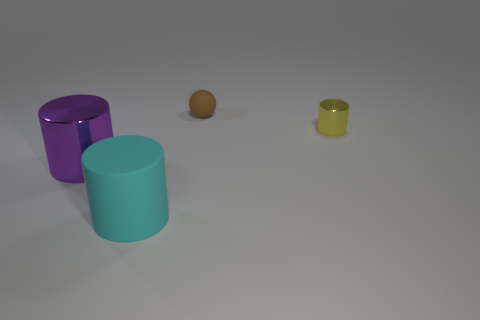Add 3 small brown matte objects. How many objects exist? 7 Subtract all cylinders. How many objects are left? 1 Add 3 brown spheres. How many brown spheres are left? 4 Add 3 brown objects. How many brown objects exist? 4 Subtract 0 blue cubes. How many objects are left? 4 Subtract all blue objects. Subtract all tiny yellow objects. How many objects are left? 3 